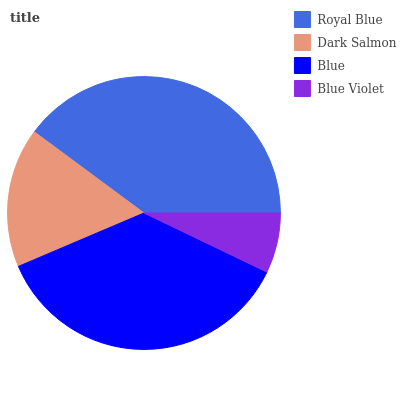Is Blue Violet the minimum?
Answer yes or no. Yes. Is Royal Blue the maximum?
Answer yes or no. Yes. Is Dark Salmon the minimum?
Answer yes or no. No. Is Dark Salmon the maximum?
Answer yes or no. No. Is Royal Blue greater than Dark Salmon?
Answer yes or no. Yes. Is Dark Salmon less than Royal Blue?
Answer yes or no. Yes. Is Dark Salmon greater than Royal Blue?
Answer yes or no. No. Is Royal Blue less than Dark Salmon?
Answer yes or no. No. Is Blue the high median?
Answer yes or no. Yes. Is Dark Salmon the low median?
Answer yes or no. Yes. Is Royal Blue the high median?
Answer yes or no. No. Is Blue the low median?
Answer yes or no. No. 